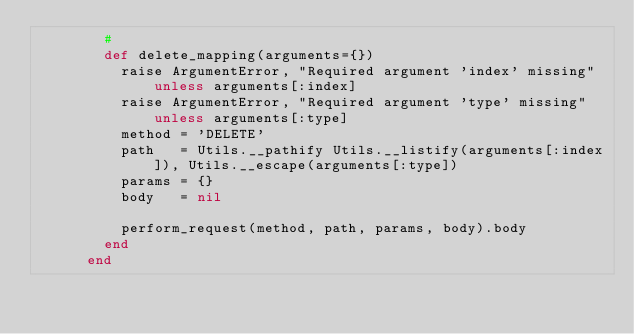<code> <loc_0><loc_0><loc_500><loc_500><_Ruby_>        #
        def delete_mapping(arguments={})
          raise ArgumentError, "Required argument 'index' missing" unless arguments[:index]
          raise ArgumentError, "Required argument 'type' missing"  unless arguments[:type]
          method = 'DELETE'
          path   = Utils.__pathify Utils.__listify(arguments[:index]), Utils.__escape(arguments[:type])
          params = {}
          body   = nil

          perform_request(method, path, params, body).body
        end
      end</code> 